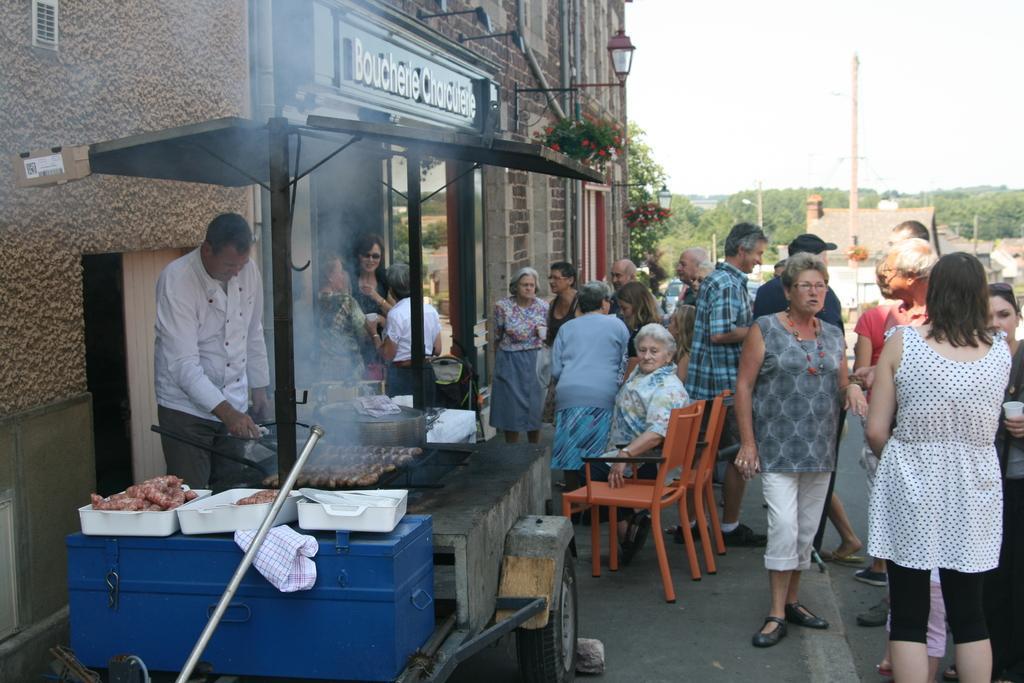Please provide a concise description of this image. In this image i can see a group of people standing on a street, some chairs and a food truck. I can see a person cooking the food and in the background i can see a building, trees and a sky. 